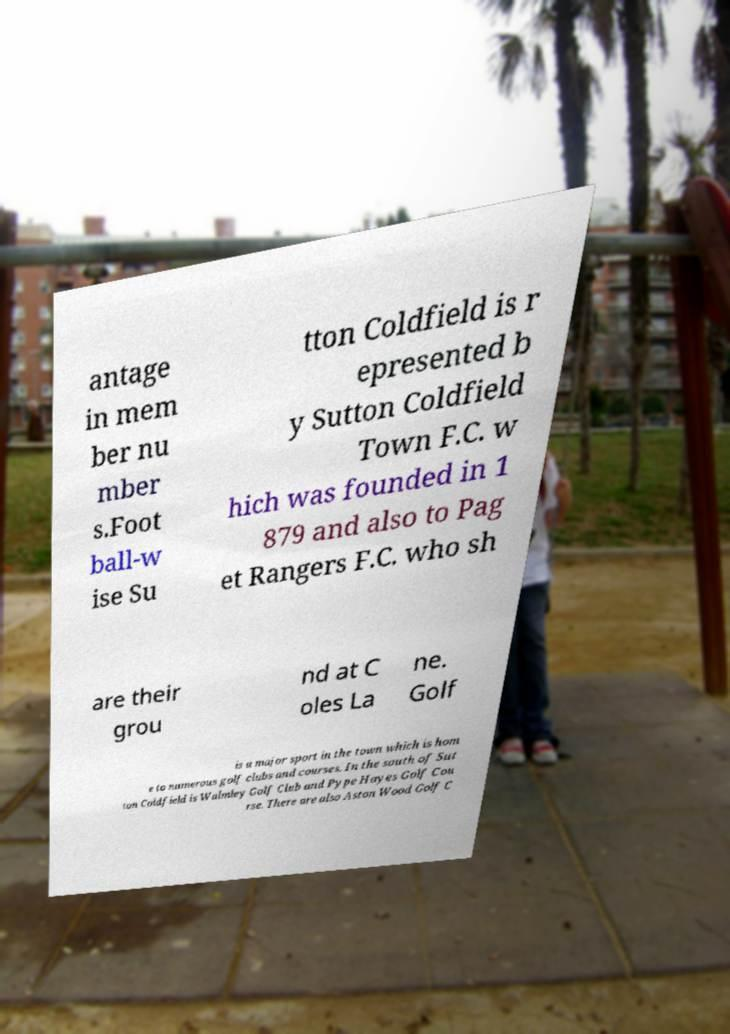Can you read and provide the text displayed in the image?This photo seems to have some interesting text. Can you extract and type it out for me? antage in mem ber nu mber s.Foot ball-w ise Su tton Coldfield is r epresented b y Sutton Coldfield Town F.C. w hich was founded in 1 879 and also to Pag et Rangers F.C. who sh are their grou nd at C oles La ne. Golf is a major sport in the town which is hom e to numerous golf clubs and courses. In the south of Sut ton Coldfield is Walmley Golf Club and Pype Hayes Golf Cou rse. There are also Aston Wood Golf C 